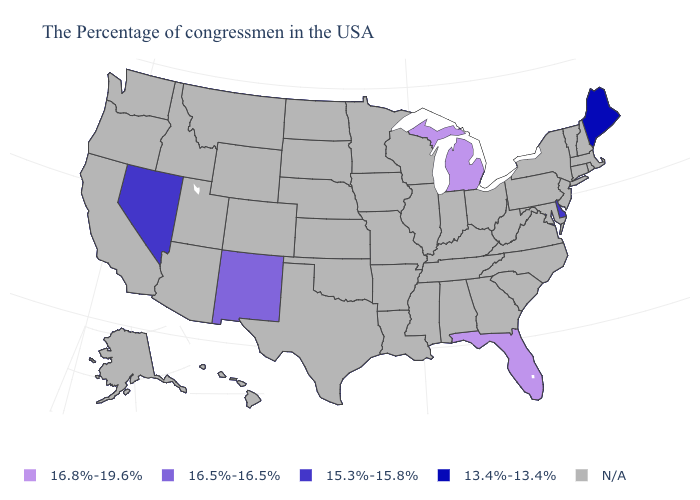What is the value of Ohio?
Quick response, please. N/A. What is the value of Nevada?
Keep it brief. 15.3%-15.8%. Name the states that have a value in the range N/A?
Concise answer only. Massachusetts, Rhode Island, New Hampshire, Vermont, Connecticut, New York, New Jersey, Maryland, Pennsylvania, Virginia, North Carolina, South Carolina, West Virginia, Ohio, Georgia, Kentucky, Indiana, Alabama, Tennessee, Wisconsin, Illinois, Mississippi, Louisiana, Missouri, Arkansas, Minnesota, Iowa, Kansas, Nebraska, Oklahoma, Texas, South Dakota, North Dakota, Wyoming, Colorado, Utah, Montana, Arizona, Idaho, California, Washington, Oregon, Alaska, Hawaii. Which states have the lowest value in the USA?
Concise answer only. Maine. What is the value of Vermont?
Give a very brief answer. N/A. What is the value of Kansas?
Give a very brief answer. N/A. What is the value of South Carolina?
Short answer required. N/A. Name the states that have a value in the range 16.5%-16.5%?
Quick response, please. New Mexico. Is the legend a continuous bar?
Concise answer only. No. What is the value of Vermont?
Answer briefly. N/A. Name the states that have a value in the range 16.8%-19.6%?
Write a very short answer. Florida, Michigan. Is the legend a continuous bar?
Short answer required. No. Name the states that have a value in the range 16.8%-19.6%?
Concise answer only. Florida, Michigan. 